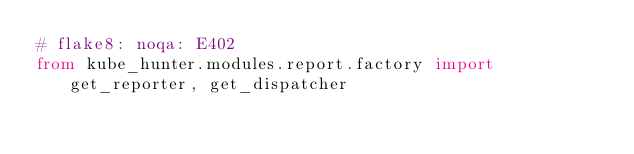Convert code to text. <code><loc_0><loc_0><loc_500><loc_500><_Python_># flake8: noqa: E402
from kube_hunter.modules.report.factory import get_reporter, get_dispatcher
</code> 